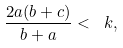Convert formula to latex. <formula><loc_0><loc_0><loc_500><loc_500>\frac { 2 a ( b + c ) } { b + a } < \ k ,</formula> 